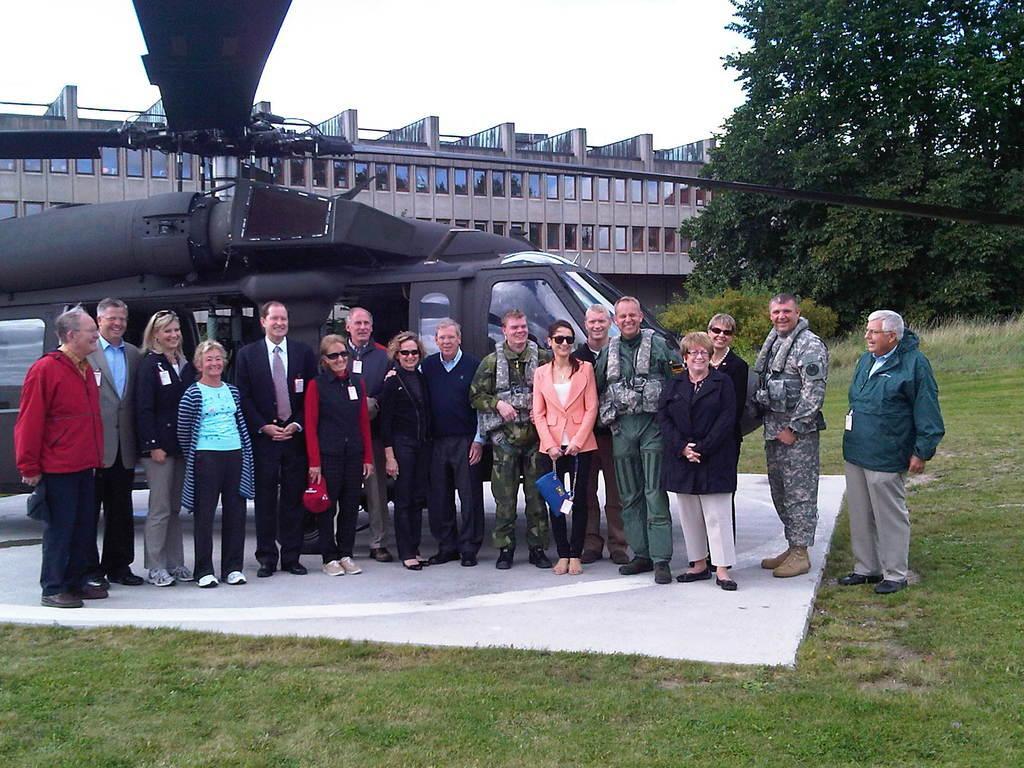Could you give a brief overview of what you see in this image? In the image we can see there are many people standing, they are wearing clothes and some of them are wearing goggles, and carrying objects in their hands. Here we can see grass, a helicopter and the tree. Here we can see the building and the windows of the building and the sky. 